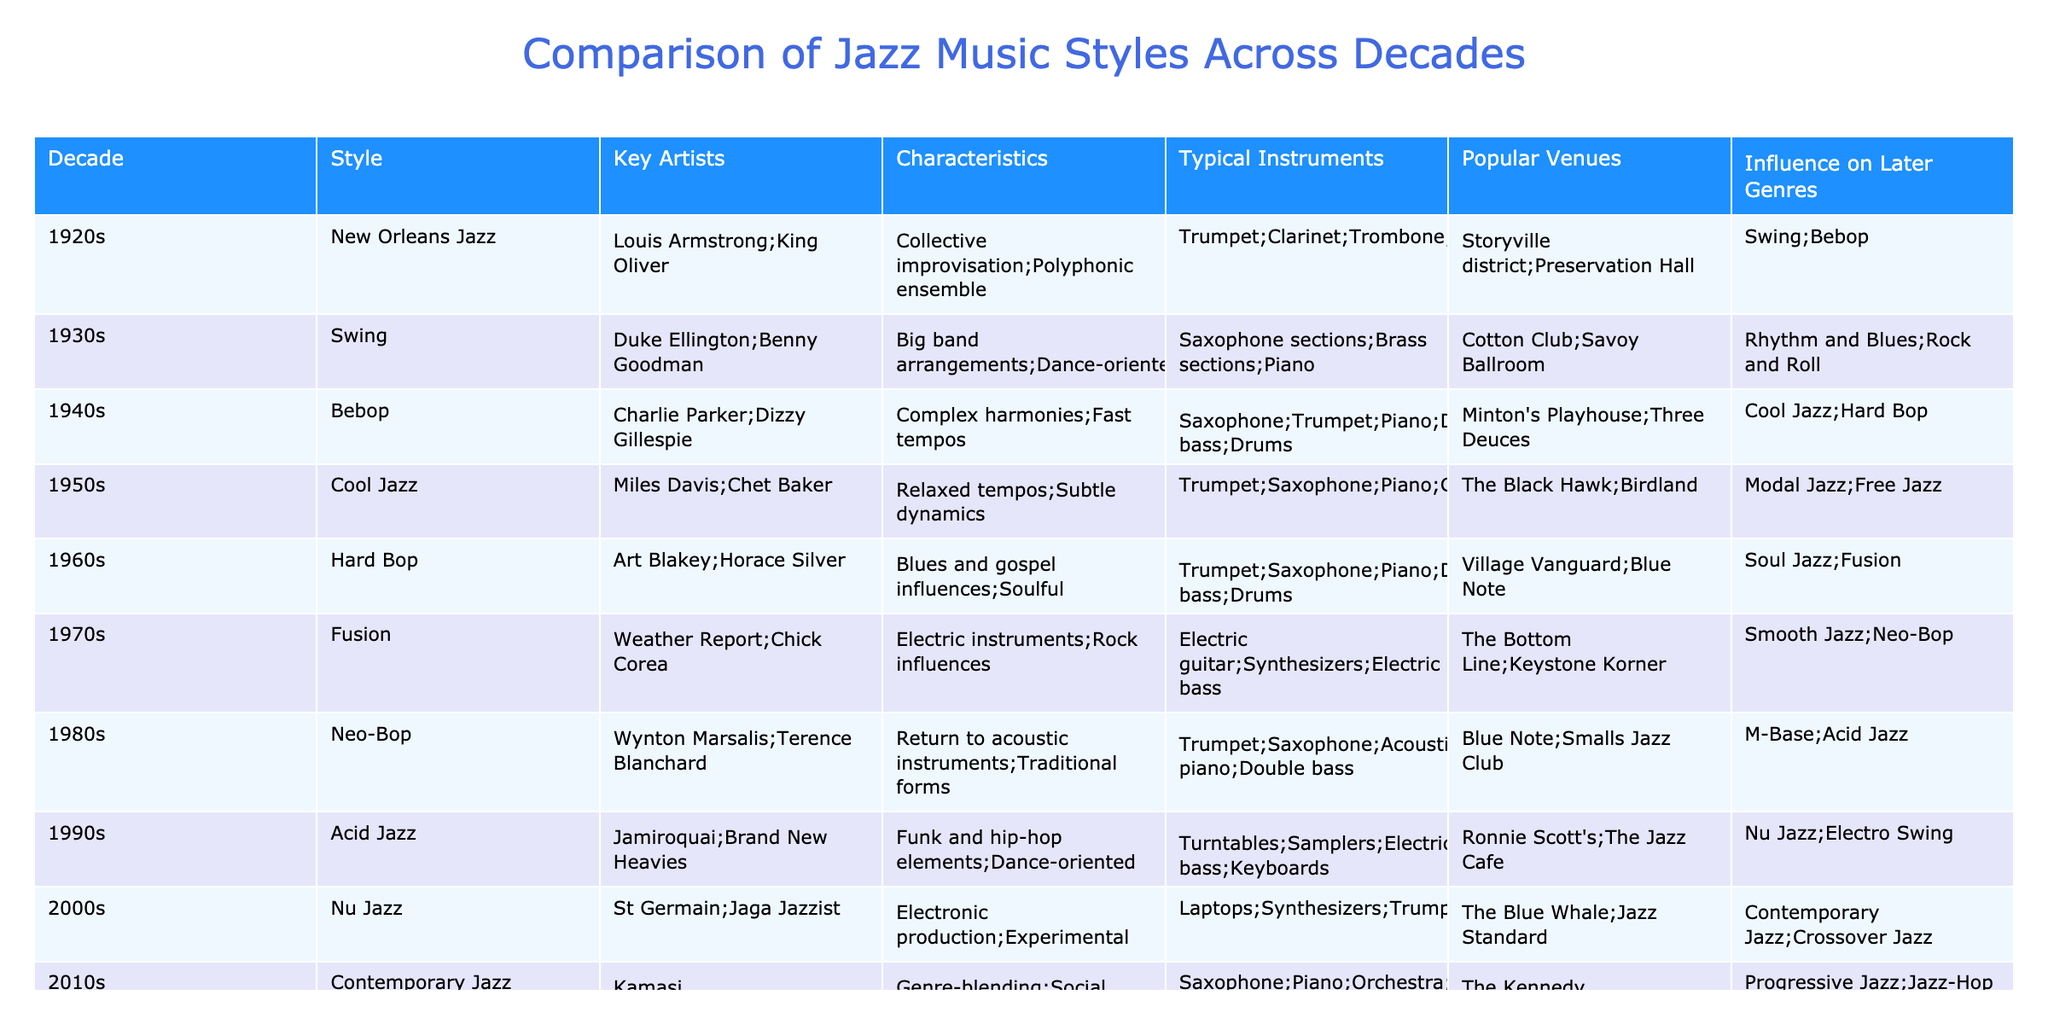What jazz style was prominent in the 1960s? In the table under the decade 1960s, the style listed is "Hard Bop." This can be directly retrieved by looking at the "Style" column matched with the "Decade" for 1960s.
Answer: Hard Bop Which instruments are typical for Cool Jazz? From the row corresponding to "Cool Jazz," the typical instruments mentioned are trumpet, saxophone, piano, and guitar. By locating the 1950s decade and navigating to the respective columns, this information is easily accessible.
Answer: Trumpet; Saxophone; Piano; Guitar Was Acid Jazz influenced by Funk and Hip-Hop elements? Looking at the entry for "Acid Jazz" in the 1990s, it specifically states that it includes funk and hip-hop elements. Hence, the fact is confirmed by directly referencing this part of the table.
Answer: Yes What decade saw the emergence of Bebop, and who were the key artists? The table indicates that Bebop emerged in the 1940s, with key artists listed as Charlie Parker and Dizzy Gillespie, proving that both aspects (the decade and the key artists) can be found within the same row for Bebop.
Answer: 1940s; Charlie Parker; Dizzy Gillespie How many decades are represented in the table, and which decade featured the most artists? The table features 10 decades from the 1920s to the 2010s. By examining the "Key Artists" entries, one can count the number of artists listed in each decade, and sequentially, one would notice an equal 2 artists for some decades such as the 80s and 90s. However, the 60s (Hard Bop) features 2 distinguished artists too. The answer encompasses both inquiries, confirmed through counting entries in relevant columns.
Answer: 10 decades; 2 artists (in multiple decades) What percentage of the key artists from the 1920s are also known for later jazz styles? In the 1920s, there are 2 key artists (Louis Armstrong and King Oliver). From the later styles listed, Louis Armstrong goes on to influence styles up to the 1960s. To find the percentage, we note 1 out of 2 artists later influenced jazz. The calculation is (1/2) * 100 = 50%. This entails both identifying relevant artists and conducting a simple percentage calculation.
Answer: 50% 